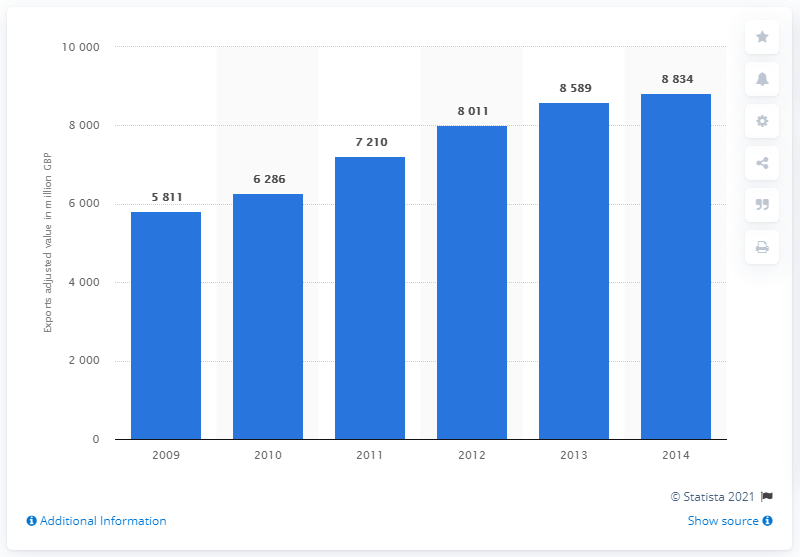Outline some significant characteristics in this image. In 2013, the value of IT, software and computer services exports was 8,589. The IT, software, and computer services industry last exported services from the United Kingdom in the year 2009. 